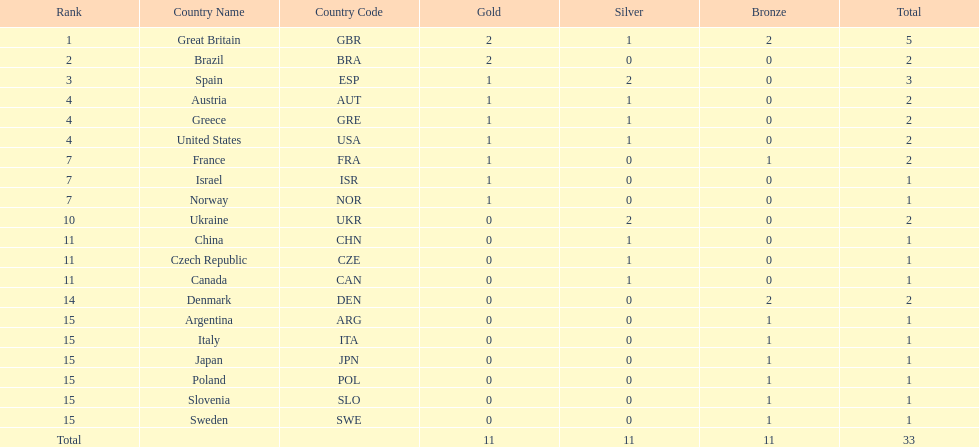How many countries won at least 2 medals in sailing? 9. 